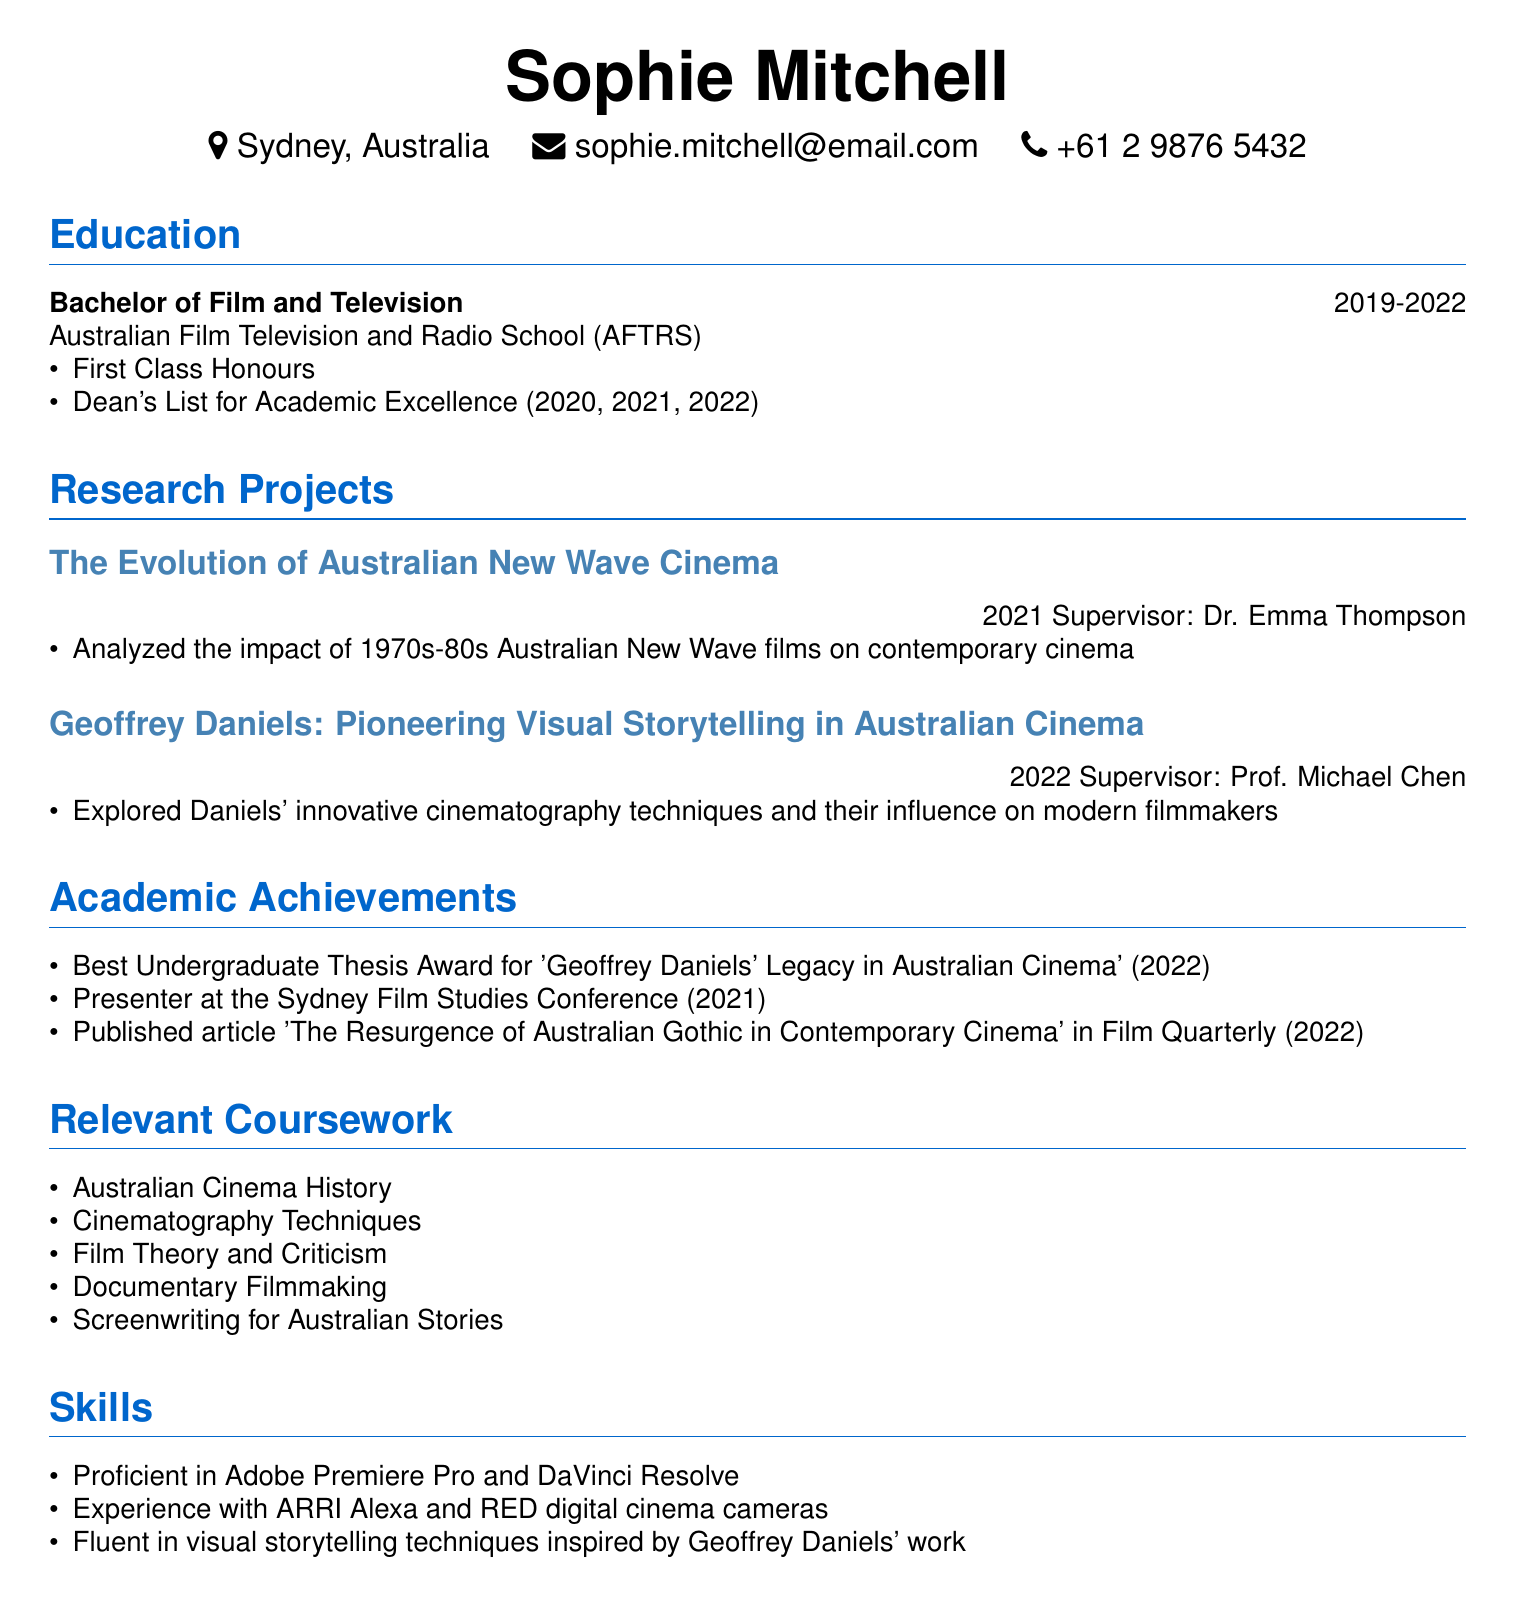What is Sophie Mitchell's degree? The document states that Sophie Mitchell holds a Bachelor of Film and Television.
Answer: Bachelor of Film and Television Which institution did Sophie attend? The document indicates that she attended the Australian Film Television and Radio School (AFTRS).
Answer: Australian Film Television and Radio School (AFTRS) What year was the research project on Geoffrey Daniels completed? The document notes that the research project titled "Geoffrey Daniels: Pioneering Visual Storytelling in Australian Cinema" was completed in 2022.
Answer: 2022 What award did Sophie receive for her undergraduate thesis? It is specified in the document that she received the Best Undergraduate Thesis Award.
Answer: Best Undergraduate Thesis Award In which year did Sophie present at the Sydney Film Studies Conference? The document mentions that Sophie presented at the conference in 2021.
Answer: 2021 Who was the supervisor for the research project on Australian New Wave Cinema? According to the document, the supervisor for this project was Dr. Emma Thompson.
Answer: Dr. Emma Thompson What are Sophie’s skills related to software? The document lists that Sophie is proficient in Adobe Premiere Pro and DaVinci Resolve.
Answer: Adobe Premiere Pro and DaVinci Resolve What was the topic of Sophie's published article? The document states that the title of the published article is "The Resurgence of Australian Gothic in Contemporary Cinema".
Answer: The Resurgence of Australian Gothic in Contemporary Cinema Which course related to film theory did Sophie take? The document lists Film Theory and Criticism as one of the relevant courses Sophie completed.
Answer: Film Theory and Criticism 